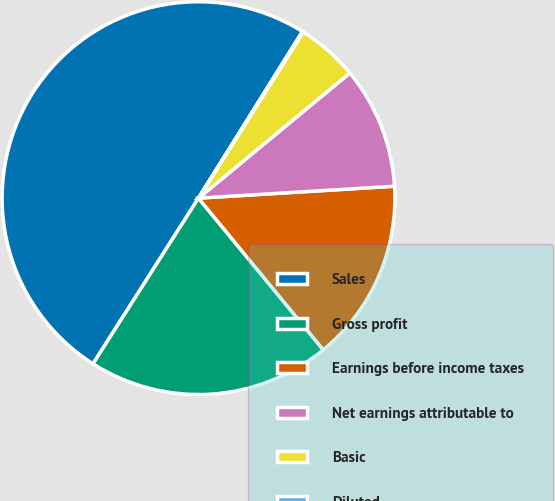Convert chart. <chart><loc_0><loc_0><loc_500><loc_500><pie_chart><fcel>Sales<fcel>Gross profit<fcel>Earnings before income taxes<fcel>Net earnings attributable to<fcel>Basic<fcel>Diluted<nl><fcel>49.85%<fcel>19.98%<fcel>15.01%<fcel>10.03%<fcel>5.05%<fcel>0.08%<nl></chart> 